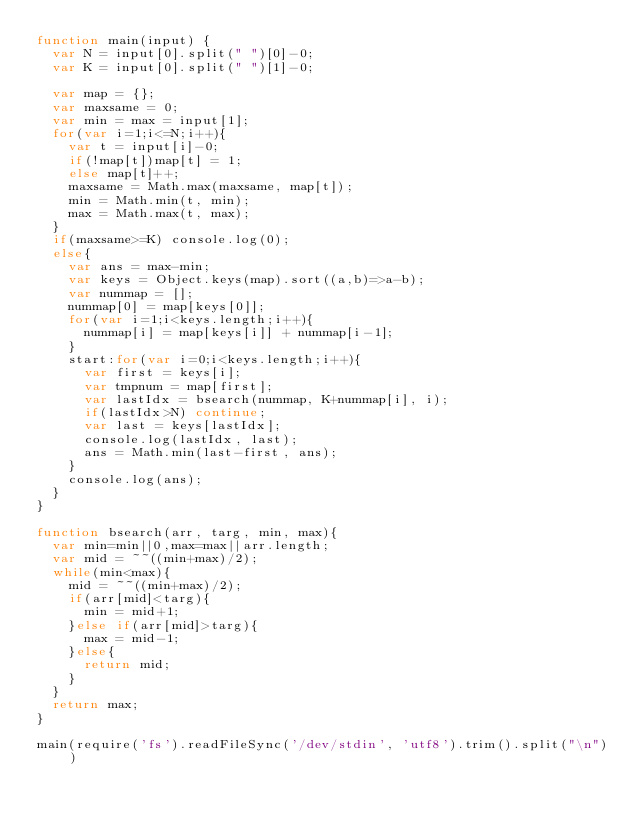Convert code to text. <code><loc_0><loc_0><loc_500><loc_500><_JavaScript_>function main(input) {
  var N = input[0].split(" ")[0]-0;
  var K = input[0].split(" ")[1]-0;

  var map = {};
  var maxsame = 0;
  var min = max = input[1];
  for(var i=1;i<=N;i++){
    var t = input[i]-0;
    if(!map[t])map[t] = 1;
    else map[t]++;
    maxsame = Math.max(maxsame, map[t]);
    min = Math.min(t, min);
    max = Math.max(t, max);
  }
  if(maxsame>=K) console.log(0);
  else{
    var ans = max-min;
    var keys = Object.keys(map).sort((a,b)=>a-b);
    var nummap = [];
    nummap[0] = map[keys[0]];
    for(var i=1;i<keys.length;i++){
      nummap[i] = map[keys[i]] + nummap[i-1];
    }
    start:for(var i=0;i<keys.length;i++){
      var first = keys[i];
      var tmpnum = map[first];
      var lastIdx = bsearch(nummap, K+nummap[i], i);
      if(lastIdx>N) continue;
      var last = keys[lastIdx];
      console.log(lastIdx, last);
      ans = Math.min(last-first, ans);
    }
    console.log(ans);
  }
}

function bsearch(arr, targ, min, max){
  var min=min||0,max=max||arr.length;
  var mid = ~~((min+max)/2);
  while(min<max){
    mid = ~~((min+max)/2);
    if(arr[mid]<targ){
      min = mid+1;
    }else if(arr[mid]>targ){
      max = mid-1;
    }else{
      return mid;
    }
  }
  return max;
}

main(require('fs').readFileSync('/dev/stdin', 'utf8').trim().split("\n"))
</code> 